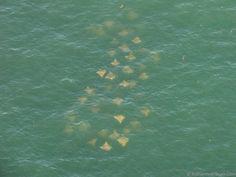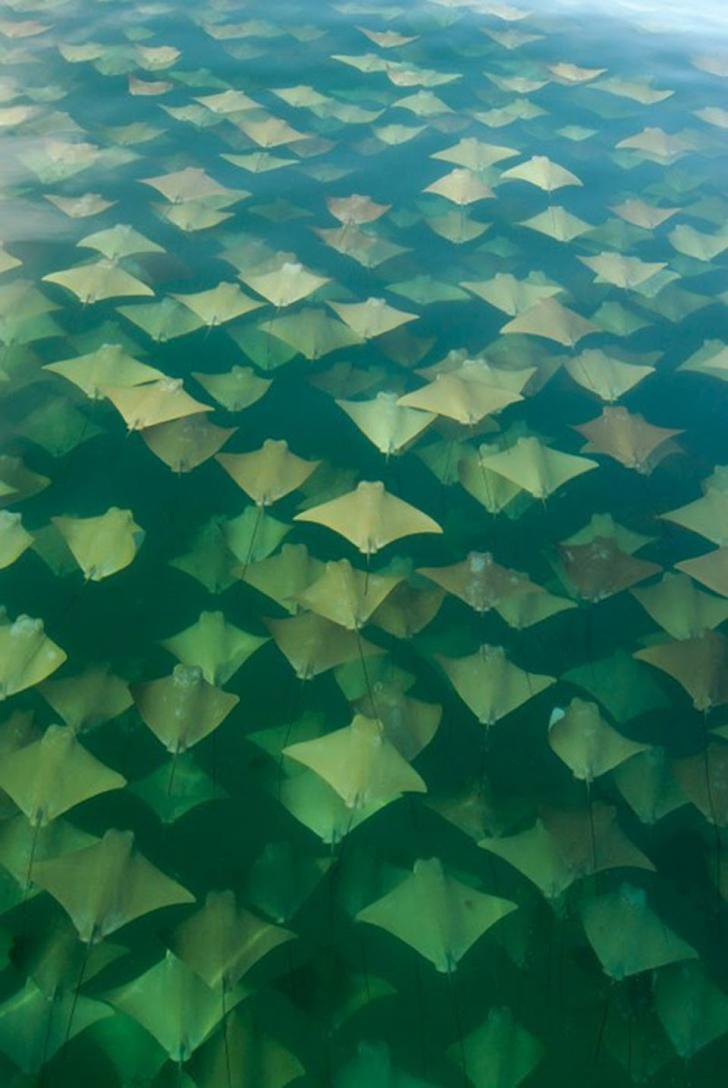The first image is the image on the left, the second image is the image on the right. Assess this claim about the two images: "There are no more than 8 creatures in the image on the right.". Correct or not? Answer yes or no. No. 